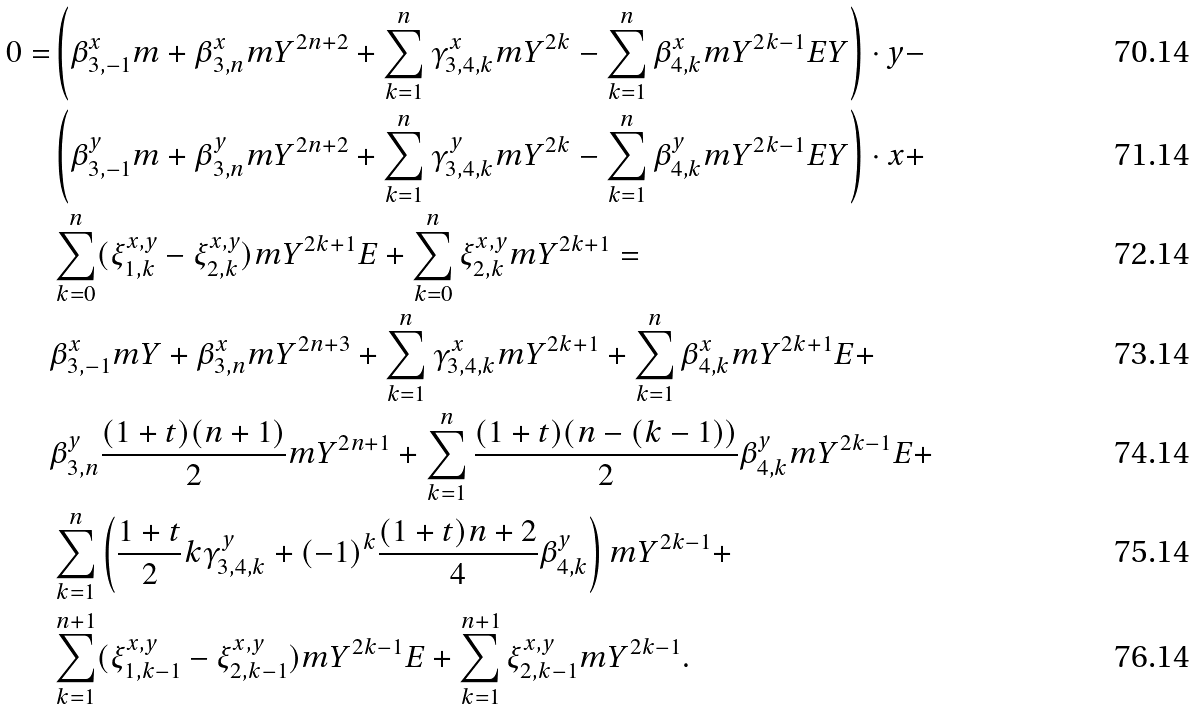<formula> <loc_0><loc_0><loc_500><loc_500>0 = & \left ( \beta _ { 3 , - 1 } ^ { x } m + \beta _ { 3 , n } ^ { x } m Y ^ { 2 n + 2 } + \sum _ { k = 1 } ^ { n } \gamma _ { 3 , 4 , k } ^ { x } m Y ^ { 2 k } - \sum _ { k = 1 } ^ { n } \beta _ { 4 , k } ^ { x } m Y ^ { 2 k - 1 } E Y \right ) \cdot y - \\ & \left ( \beta _ { 3 , - 1 } ^ { y } m + \beta _ { 3 , n } ^ { y } m Y ^ { 2 n + 2 } + \sum _ { k = 1 } ^ { n } \gamma _ { 3 , 4 , k } ^ { y } m Y ^ { 2 k } - \sum _ { k = 1 } ^ { n } \beta _ { 4 , k } ^ { y } m Y ^ { 2 k - 1 } E Y \right ) \cdot x + \\ & \sum _ { k = 0 } ^ { n } ( \xi _ { 1 , k } ^ { x , y } - \xi _ { 2 , k } ^ { x , y } ) m Y ^ { 2 k + 1 } E + \sum _ { k = 0 } ^ { n } \xi _ { 2 , k } ^ { x , y } m Y ^ { 2 k + 1 } = \\ & \beta _ { 3 , - 1 } ^ { x } m Y + \beta _ { 3 , n } ^ { x } m Y ^ { 2 n + 3 } + \sum _ { k = 1 } ^ { n } \gamma _ { 3 , 4 , k } ^ { x } m Y ^ { 2 k + 1 } + \sum _ { k = 1 } ^ { n } \beta _ { 4 , k } ^ { x } m Y ^ { 2 k + 1 } E + \\ & \beta _ { 3 , n } ^ { y } \frac { ( 1 + t ) ( n + 1 ) } { 2 } m Y ^ { 2 n + 1 } + \sum _ { k = 1 } ^ { n } \frac { ( 1 + t ) ( n - ( k - 1 ) ) } { 2 } \beta _ { 4 , k } ^ { y } m Y ^ { 2 k - 1 } E + \\ & \sum _ { k = 1 } ^ { n } \left ( \frac { 1 + t } { 2 } k \gamma _ { 3 , 4 , k } ^ { y } + ( - 1 ) ^ { k } \frac { ( 1 + t ) n + 2 } { 4 } \beta _ { 4 , k } ^ { y } \right ) m Y ^ { 2 k - 1 } + \\ & \sum _ { k = 1 } ^ { n + 1 } ( \xi _ { 1 , k - 1 } ^ { x , y } - \xi _ { 2 , k - 1 } ^ { x , y } ) m Y ^ { 2 k - 1 } E + \sum _ { k = 1 } ^ { n + 1 } \xi _ { 2 , k - 1 } ^ { x , y } m Y ^ { 2 k - 1 } .</formula> 